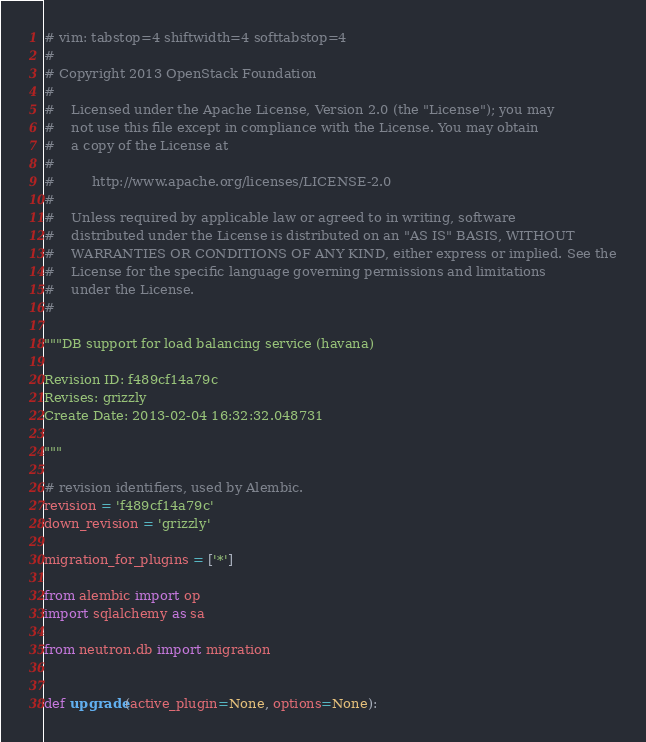<code> <loc_0><loc_0><loc_500><loc_500><_Python_># vim: tabstop=4 shiftwidth=4 softtabstop=4
#
# Copyright 2013 OpenStack Foundation
#
#    Licensed under the Apache License, Version 2.0 (the "License"); you may
#    not use this file except in compliance with the License. You may obtain
#    a copy of the License at
#
#         http://www.apache.org/licenses/LICENSE-2.0
#
#    Unless required by applicable law or agreed to in writing, software
#    distributed under the License is distributed on an "AS IS" BASIS, WITHOUT
#    WARRANTIES OR CONDITIONS OF ANY KIND, either express or implied. See the
#    License for the specific language governing permissions and limitations
#    under the License.
#

"""DB support for load balancing service (havana)

Revision ID: f489cf14a79c
Revises: grizzly
Create Date: 2013-02-04 16:32:32.048731

"""

# revision identifiers, used by Alembic.
revision = 'f489cf14a79c'
down_revision = 'grizzly'

migration_for_plugins = ['*']

from alembic import op
import sqlalchemy as sa

from neutron.db import migration


def upgrade(active_plugin=None, options=None):</code> 